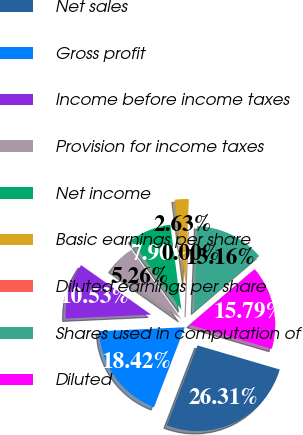Convert chart. <chart><loc_0><loc_0><loc_500><loc_500><pie_chart><fcel>Net sales<fcel>Gross profit<fcel>Income before income taxes<fcel>Provision for income taxes<fcel>Net income<fcel>Basic earnings per share<fcel>Diluted earnings per share<fcel>Shares used in computation of<fcel>Diluted<nl><fcel>26.31%<fcel>18.42%<fcel>10.53%<fcel>5.26%<fcel>7.9%<fcel>2.63%<fcel>0.0%<fcel>13.16%<fcel>15.79%<nl></chart> 